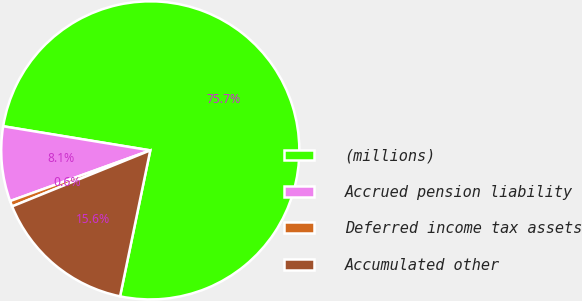Convert chart to OTSL. <chart><loc_0><loc_0><loc_500><loc_500><pie_chart><fcel>(millions)<fcel>Accrued pension liability<fcel>Deferred income tax assets<fcel>Accumulated other<nl><fcel>75.66%<fcel>8.11%<fcel>0.61%<fcel>15.62%<nl></chart> 